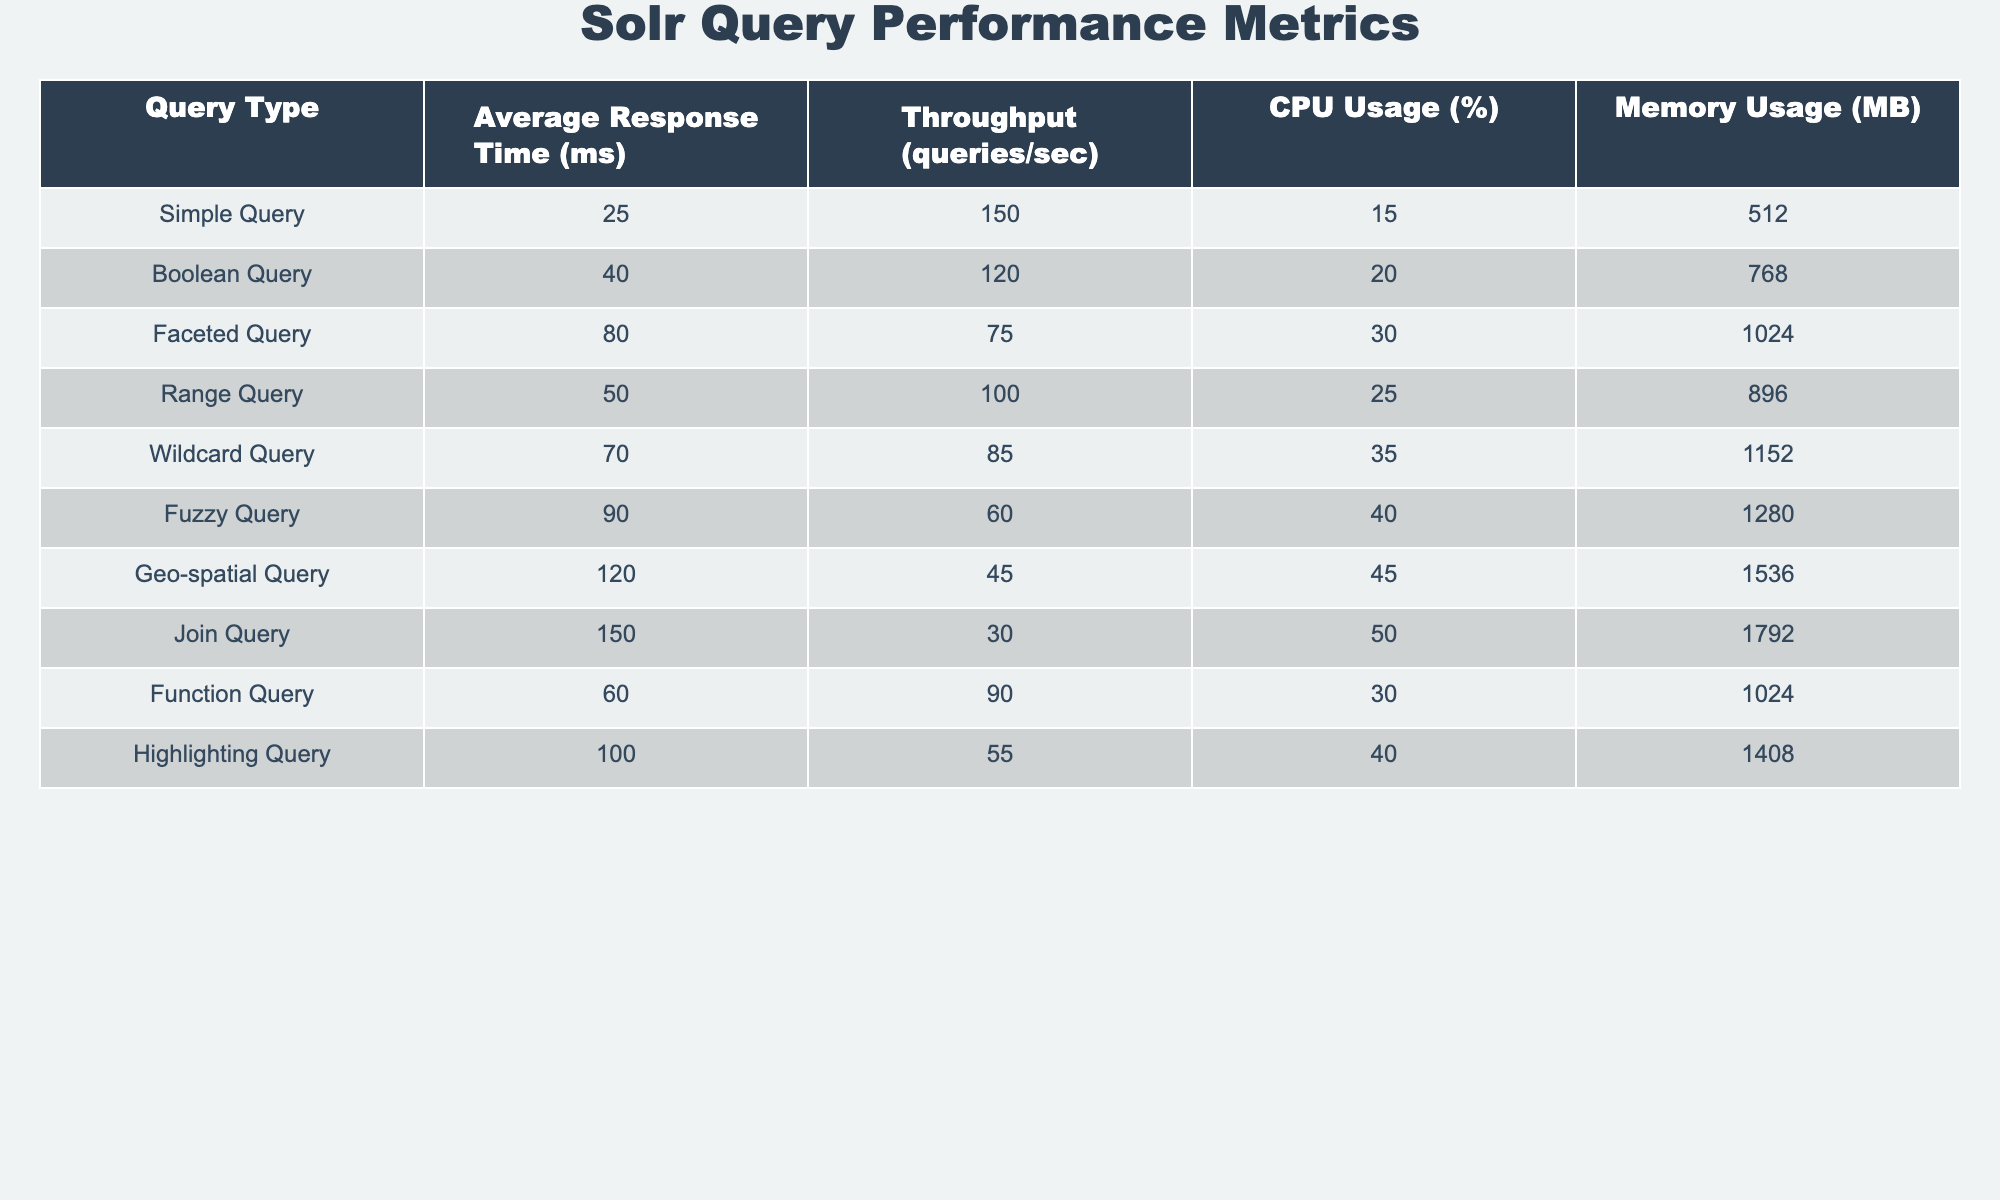What is the average response time of a Boolean query? The table shows that the average response time for a Boolean Query is 40 milliseconds.
Answer: 40 ms Which query type has the highest CPU usage? According to the table, the Geo-spatial Query has the highest CPU usage at 45%.
Answer: 45% What is the difference in average response time between the Fuzzy Query and the Join Query? The average response time for the Fuzzy Query is 90 ms and for the Join Query it is 150 ms. The difference is calculated as 150 - 90 = 60 ms.
Answer: 60 ms Is the memory usage of a Wildcard Query greater than that of a Simple Query? The table indicates that the Wildcard Query has a memory usage of 1152 MB while the Simple Query has 512 MB. Since 1152 MB is greater than 512 MB, the answer is yes.
Answer: Yes What is the total throughput of all query types combined? To find the total throughput, we need to sum up the throughput values: 150 + 120 + 75 + 100 + 85 + 60 + 45 + 30 + 90 + 55 = 1010 queries/sec.
Answer: 1010 queries/sec Which query type has the lowest throughput? The table reveals that the Fuzzy Query has the lowest throughput at 60 queries/sec.
Answer: 60 queries/sec What is the average memory usage of Faceted and Highlighting Queries combined? To find the average memory usage, we sum the memory usage of both queries: 1024 MB (Faceted) + 1408 MB (Highlighting) = 2432 MB, then divide by 2 to get the average: 2432 / 2 = 1216 MB.
Answer: 1216 MB Does the Range Query have a higher average response time than the Simple Query? The average response time for the Range Query is 50 ms, while for the Simple Query it is 25 ms. Since 50 ms is greater than 25 ms, the answer is yes.
Answer: Yes What is the ratio of the throughput of a Boolean Query to a Fuzzy Query? The throughput of a Boolean Query is 120 queries/sec and that of a Fuzzy Query is 60 queries/sec. The ratio is calculated as 120/60 = 2.
Answer: 2 